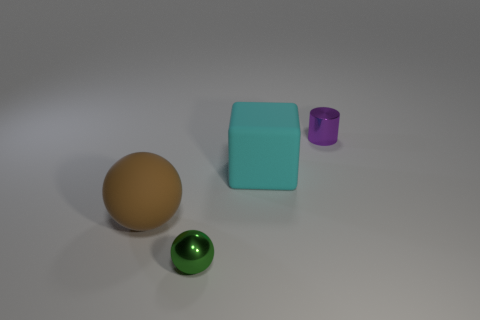Add 4 tiny metal spheres. How many objects exist? 8 Subtract all cylinders. How many objects are left? 3 Subtract 0 red spheres. How many objects are left? 4 Subtract all large purple metallic cylinders. Subtract all purple metal things. How many objects are left? 3 Add 4 small purple shiny objects. How many small purple shiny objects are left? 5 Add 1 green rubber balls. How many green rubber balls exist? 1 